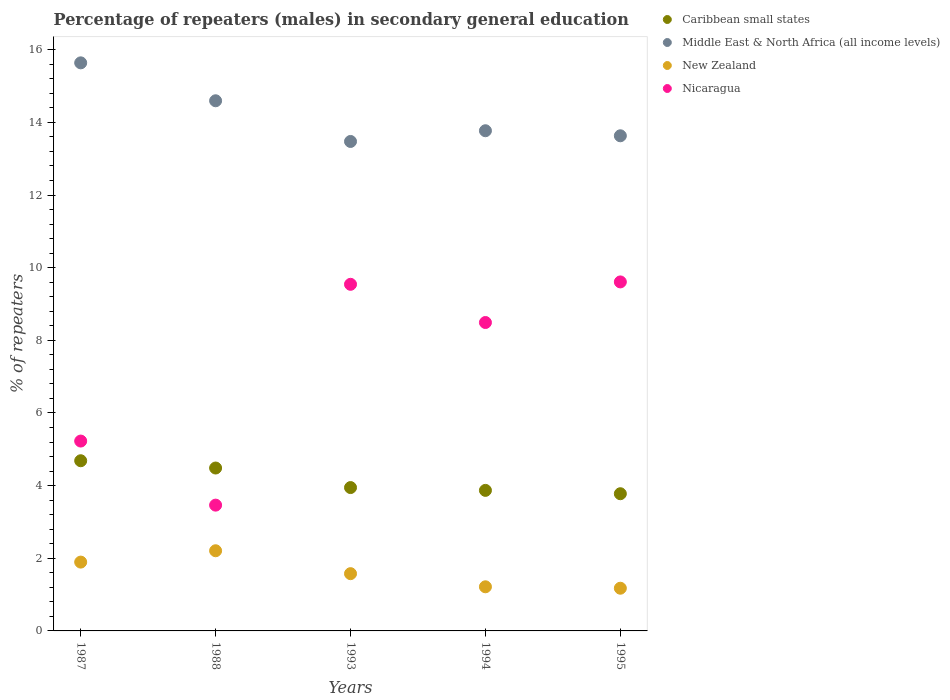How many different coloured dotlines are there?
Provide a short and direct response. 4. Is the number of dotlines equal to the number of legend labels?
Your response must be concise. Yes. What is the percentage of male repeaters in Nicaragua in 1995?
Offer a terse response. 9.61. Across all years, what is the maximum percentage of male repeaters in Nicaragua?
Provide a short and direct response. 9.61. Across all years, what is the minimum percentage of male repeaters in Nicaragua?
Your response must be concise. 3.46. In which year was the percentage of male repeaters in New Zealand maximum?
Make the answer very short. 1988. What is the total percentage of male repeaters in New Zealand in the graph?
Your answer should be very brief. 8.07. What is the difference between the percentage of male repeaters in Caribbean small states in 1993 and that in 1994?
Offer a very short reply. 0.08. What is the difference between the percentage of male repeaters in New Zealand in 1988 and the percentage of male repeaters in Nicaragua in 1987?
Your answer should be compact. -3.02. What is the average percentage of male repeaters in New Zealand per year?
Your response must be concise. 1.61. In the year 1987, what is the difference between the percentage of male repeaters in Middle East & North Africa (all income levels) and percentage of male repeaters in Caribbean small states?
Offer a terse response. 10.95. What is the ratio of the percentage of male repeaters in Middle East & North Africa (all income levels) in 1987 to that in 1994?
Your response must be concise. 1.14. What is the difference between the highest and the second highest percentage of male repeaters in Middle East & North Africa (all income levels)?
Provide a succinct answer. 1.04. What is the difference between the highest and the lowest percentage of male repeaters in Caribbean small states?
Keep it short and to the point. 0.91. Is it the case that in every year, the sum of the percentage of male repeaters in Caribbean small states and percentage of male repeaters in New Zealand  is greater than the sum of percentage of male repeaters in Nicaragua and percentage of male repeaters in Middle East & North Africa (all income levels)?
Offer a terse response. No. Is it the case that in every year, the sum of the percentage of male repeaters in Middle East & North Africa (all income levels) and percentage of male repeaters in Nicaragua  is greater than the percentage of male repeaters in Caribbean small states?
Offer a terse response. Yes. Does the percentage of male repeaters in Middle East & North Africa (all income levels) monotonically increase over the years?
Make the answer very short. No. How many legend labels are there?
Your response must be concise. 4. What is the title of the graph?
Keep it short and to the point. Percentage of repeaters (males) in secondary general education. What is the label or title of the X-axis?
Provide a succinct answer. Years. What is the label or title of the Y-axis?
Provide a succinct answer. % of repeaters. What is the % of repeaters of Caribbean small states in 1987?
Provide a short and direct response. 4.68. What is the % of repeaters of Middle East & North Africa (all income levels) in 1987?
Offer a terse response. 15.64. What is the % of repeaters in New Zealand in 1987?
Your answer should be compact. 1.89. What is the % of repeaters of Nicaragua in 1987?
Give a very brief answer. 5.23. What is the % of repeaters in Caribbean small states in 1988?
Make the answer very short. 4.48. What is the % of repeaters in Middle East & North Africa (all income levels) in 1988?
Ensure brevity in your answer.  14.59. What is the % of repeaters in New Zealand in 1988?
Keep it short and to the point. 2.21. What is the % of repeaters of Nicaragua in 1988?
Provide a short and direct response. 3.46. What is the % of repeaters of Caribbean small states in 1993?
Keep it short and to the point. 3.95. What is the % of repeaters in Middle East & North Africa (all income levels) in 1993?
Offer a very short reply. 13.47. What is the % of repeaters of New Zealand in 1993?
Your answer should be compact. 1.58. What is the % of repeaters of Nicaragua in 1993?
Your response must be concise. 9.54. What is the % of repeaters in Caribbean small states in 1994?
Make the answer very short. 3.87. What is the % of repeaters in Middle East & North Africa (all income levels) in 1994?
Keep it short and to the point. 13.77. What is the % of repeaters in New Zealand in 1994?
Make the answer very short. 1.21. What is the % of repeaters in Nicaragua in 1994?
Your response must be concise. 8.49. What is the % of repeaters in Caribbean small states in 1995?
Provide a short and direct response. 3.78. What is the % of repeaters in Middle East & North Africa (all income levels) in 1995?
Give a very brief answer. 13.63. What is the % of repeaters in New Zealand in 1995?
Provide a short and direct response. 1.18. What is the % of repeaters of Nicaragua in 1995?
Provide a succinct answer. 9.61. Across all years, what is the maximum % of repeaters of Caribbean small states?
Provide a succinct answer. 4.68. Across all years, what is the maximum % of repeaters in Middle East & North Africa (all income levels)?
Your answer should be very brief. 15.64. Across all years, what is the maximum % of repeaters in New Zealand?
Your answer should be very brief. 2.21. Across all years, what is the maximum % of repeaters in Nicaragua?
Provide a short and direct response. 9.61. Across all years, what is the minimum % of repeaters in Caribbean small states?
Provide a succinct answer. 3.78. Across all years, what is the minimum % of repeaters in Middle East & North Africa (all income levels)?
Make the answer very short. 13.47. Across all years, what is the minimum % of repeaters in New Zealand?
Your answer should be compact. 1.18. Across all years, what is the minimum % of repeaters of Nicaragua?
Make the answer very short. 3.46. What is the total % of repeaters in Caribbean small states in the graph?
Your response must be concise. 20.76. What is the total % of repeaters in Middle East & North Africa (all income levels) in the graph?
Your answer should be very brief. 71.1. What is the total % of repeaters of New Zealand in the graph?
Offer a very short reply. 8.07. What is the total % of repeaters in Nicaragua in the graph?
Your answer should be very brief. 36.33. What is the difference between the % of repeaters in Caribbean small states in 1987 and that in 1988?
Ensure brevity in your answer.  0.2. What is the difference between the % of repeaters in Middle East & North Africa (all income levels) in 1987 and that in 1988?
Offer a very short reply. 1.04. What is the difference between the % of repeaters of New Zealand in 1987 and that in 1988?
Your response must be concise. -0.31. What is the difference between the % of repeaters of Nicaragua in 1987 and that in 1988?
Your answer should be compact. 1.76. What is the difference between the % of repeaters in Caribbean small states in 1987 and that in 1993?
Your answer should be very brief. 0.74. What is the difference between the % of repeaters in Middle East & North Africa (all income levels) in 1987 and that in 1993?
Provide a succinct answer. 2.16. What is the difference between the % of repeaters of New Zealand in 1987 and that in 1993?
Your answer should be compact. 0.32. What is the difference between the % of repeaters in Nicaragua in 1987 and that in 1993?
Offer a very short reply. -4.32. What is the difference between the % of repeaters of Caribbean small states in 1987 and that in 1994?
Offer a terse response. 0.82. What is the difference between the % of repeaters of Middle East & North Africa (all income levels) in 1987 and that in 1994?
Offer a very short reply. 1.87. What is the difference between the % of repeaters in New Zealand in 1987 and that in 1994?
Your answer should be very brief. 0.68. What is the difference between the % of repeaters of Nicaragua in 1987 and that in 1994?
Offer a very short reply. -3.26. What is the difference between the % of repeaters of Caribbean small states in 1987 and that in 1995?
Your response must be concise. 0.91. What is the difference between the % of repeaters of Middle East & North Africa (all income levels) in 1987 and that in 1995?
Keep it short and to the point. 2.01. What is the difference between the % of repeaters in New Zealand in 1987 and that in 1995?
Offer a terse response. 0.72. What is the difference between the % of repeaters of Nicaragua in 1987 and that in 1995?
Offer a terse response. -4.38. What is the difference between the % of repeaters in Caribbean small states in 1988 and that in 1993?
Provide a succinct answer. 0.54. What is the difference between the % of repeaters of Middle East & North Africa (all income levels) in 1988 and that in 1993?
Your answer should be very brief. 1.12. What is the difference between the % of repeaters in New Zealand in 1988 and that in 1993?
Provide a short and direct response. 0.63. What is the difference between the % of repeaters in Nicaragua in 1988 and that in 1993?
Your answer should be very brief. -6.08. What is the difference between the % of repeaters of Caribbean small states in 1988 and that in 1994?
Give a very brief answer. 0.62. What is the difference between the % of repeaters in Middle East & North Africa (all income levels) in 1988 and that in 1994?
Provide a short and direct response. 0.82. What is the difference between the % of repeaters of New Zealand in 1988 and that in 1994?
Offer a terse response. 0.99. What is the difference between the % of repeaters of Nicaragua in 1988 and that in 1994?
Provide a short and direct response. -5.03. What is the difference between the % of repeaters of Caribbean small states in 1988 and that in 1995?
Keep it short and to the point. 0.71. What is the difference between the % of repeaters in Middle East & North Africa (all income levels) in 1988 and that in 1995?
Offer a terse response. 0.96. What is the difference between the % of repeaters of New Zealand in 1988 and that in 1995?
Your answer should be compact. 1.03. What is the difference between the % of repeaters in Nicaragua in 1988 and that in 1995?
Ensure brevity in your answer.  -6.14. What is the difference between the % of repeaters of Caribbean small states in 1993 and that in 1994?
Keep it short and to the point. 0.08. What is the difference between the % of repeaters in Middle East & North Africa (all income levels) in 1993 and that in 1994?
Your answer should be very brief. -0.3. What is the difference between the % of repeaters in New Zealand in 1993 and that in 1994?
Keep it short and to the point. 0.36. What is the difference between the % of repeaters in Nicaragua in 1993 and that in 1994?
Ensure brevity in your answer.  1.05. What is the difference between the % of repeaters in Caribbean small states in 1993 and that in 1995?
Your answer should be compact. 0.17. What is the difference between the % of repeaters of Middle East & North Africa (all income levels) in 1993 and that in 1995?
Your answer should be very brief. -0.16. What is the difference between the % of repeaters in New Zealand in 1993 and that in 1995?
Offer a terse response. 0.4. What is the difference between the % of repeaters of Nicaragua in 1993 and that in 1995?
Provide a short and direct response. -0.07. What is the difference between the % of repeaters of Caribbean small states in 1994 and that in 1995?
Your answer should be very brief. 0.09. What is the difference between the % of repeaters in Middle East & North Africa (all income levels) in 1994 and that in 1995?
Provide a short and direct response. 0.14. What is the difference between the % of repeaters of New Zealand in 1994 and that in 1995?
Keep it short and to the point. 0.04. What is the difference between the % of repeaters of Nicaragua in 1994 and that in 1995?
Keep it short and to the point. -1.12. What is the difference between the % of repeaters in Caribbean small states in 1987 and the % of repeaters in Middle East & North Africa (all income levels) in 1988?
Offer a terse response. -9.91. What is the difference between the % of repeaters of Caribbean small states in 1987 and the % of repeaters of New Zealand in 1988?
Offer a terse response. 2.48. What is the difference between the % of repeaters of Caribbean small states in 1987 and the % of repeaters of Nicaragua in 1988?
Your answer should be very brief. 1.22. What is the difference between the % of repeaters of Middle East & North Africa (all income levels) in 1987 and the % of repeaters of New Zealand in 1988?
Provide a short and direct response. 13.43. What is the difference between the % of repeaters in Middle East & North Africa (all income levels) in 1987 and the % of repeaters in Nicaragua in 1988?
Provide a short and direct response. 12.18. What is the difference between the % of repeaters of New Zealand in 1987 and the % of repeaters of Nicaragua in 1988?
Your answer should be compact. -1.57. What is the difference between the % of repeaters of Caribbean small states in 1987 and the % of repeaters of Middle East & North Africa (all income levels) in 1993?
Keep it short and to the point. -8.79. What is the difference between the % of repeaters of Caribbean small states in 1987 and the % of repeaters of New Zealand in 1993?
Offer a very short reply. 3.11. What is the difference between the % of repeaters of Caribbean small states in 1987 and the % of repeaters of Nicaragua in 1993?
Your answer should be compact. -4.86. What is the difference between the % of repeaters of Middle East & North Africa (all income levels) in 1987 and the % of repeaters of New Zealand in 1993?
Your response must be concise. 14.06. What is the difference between the % of repeaters in Middle East & North Africa (all income levels) in 1987 and the % of repeaters in Nicaragua in 1993?
Your answer should be compact. 6.1. What is the difference between the % of repeaters in New Zealand in 1987 and the % of repeaters in Nicaragua in 1993?
Make the answer very short. -7.65. What is the difference between the % of repeaters in Caribbean small states in 1987 and the % of repeaters in Middle East & North Africa (all income levels) in 1994?
Ensure brevity in your answer.  -9.08. What is the difference between the % of repeaters in Caribbean small states in 1987 and the % of repeaters in New Zealand in 1994?
Provide a succinct answer. 3.47. What is the difference between the % of repeaters in Caribbean small states in 1987 and the % of repeaters in Nicaragua in 1994?
Give a very brief answer. -3.81. What is the difference between the % of repeaters in Middle East & North Africa (all income levels) in 1987 and the % of repeaters in New Zealand in 1994?
Provide a short and direct response. 14.42. What is the difference between the % of repeaters in Middle East & North Africa (all income levels) in 1987 and the % of repeaters in Nicaragua in 1994?
Offer a very short reply. 7.15. What is the difference between the % of repeaters in New Zealand in 1987 and the % of repeaters in Nicaragua in 1994?
Provide a succinct answer. -6.6. What is the difference between the % of repeaters in Caribbean small states in 1987 and the % of repeaters in Middle East & North Africa (all income levels) in 1995?
Ensure brevity in your answer.  -8.95. What is the difference between the % of repeaters of Caribbean small states in 1987 and the % of repeaters of New Zealand in 1995?
Give a very brief answer. 3.51. What is the difference between the % of repeaters in Caribbean small states in 1987 and the % of repeaters in Nicaragua in 1995?
Offer a terse response. -4.92. What is the difference between the % of repeaters of Middle East & North Africa (all income levels) in 1987 and the % of repeaters of New Zealand in 1995?
Your answer should be compact. 14.46. What is the difference between the % of repeaters in Middle East & North Africa (all income levels) in 1987 and the % of repeaters in Nicaragua in 1995?
Ensure brevity in your answer.  6.03. What is the difference between the % of repeaters in New Zealand in 1987 and the % of repeaters in Nicaragua in 1995?
Your answer should be very brief. -7.71. What is the difference between the % of repeaters of Caribbean small states in 1988 and the % of repeaters of Middle East & North Africa (all income levels) in 1993?
Offer a terse response. -8.99. What is the difference between the % of repeaters in Caribbean small states in 1988 and the % of repeaters in New Zealand in 1993?
Offer a very short reply. 2.91. What is the difference between the % of repeaters in Caribbean small states in 1988 and the % of repeaters in Nicaragua in 1993?
Offer a terse response. -5.06. What is the difference between the % of repeaters in Middle East & North Africa (all income levels) in 1988 and the % of repeaters in New Zealand in 1993?
Keep it short and to the point. 13.02. What is the difference between the % of repeaters of Middle East & North Africa (all income levels) in 1988 and the % of repeaters of Nicaragua in 1993?
Provide a succinct answer. 5.05. What is the difference between the % of repeaters in New Zealand in 1988 and the % of repeaters in Nicaragua in 1993?
Your response must be concise. -7.33. What is the difference between the % of repeaters of Caribbean small states in 1988 and the % of repeaters of Middle East & North Africa (all income levels) in 1994?
Provide a short and direct response. -9.28. What is the difference between the % of repeaters of Caribbean small states in 1988 and the % of repeaters of New Zealand in 1994?
Your answer should be compact. 3.27. What is the difference between the % of repeaters in Caribbean small states in 1988 and the % of repeaters in Nicaragua in 1994?
Offer a very short reply. -4.01. What is the difference between the % of repeaters of Middle East & North Africa (all income levels) in 1988 and the % of repeaters of New Zealand in 1994?
Your response must be concise. 13.38. What is the difference between the % of repeaters of Middle East & North Africa (all income levels) in 1988 and the % of repeaters of Nicaragua in 1994?
Your answer should be compact. 6.1. What is the difference between the % of repeaters of New Zealand in 1988 and the % of repeaters of Nicaragua in 1994?
Give a very brief answer. -6.28. What is the difference between the % of repeaters in Caribbean small states in 1988 and the % of repeaters in Middle East & North Africa (all income levels) in 1995?
Provide a short and direct response. -9.15. What is the difference between the % of repeaters of Caribbean small states in 1988 and the % of repeaters of New Zealand in 1995?
Your response must be concise. 3.31. What is the difference between the % of repeaters of Caribbean small states in 1988 and the % of repeaters of Nicaragua in 1995?
Give a very brief answer. -5.12. What is the difference between the % of repeaters in Middle East & North Africa (all income levels) in 1988 and the % of repeaters in New Zealand in 1995?
Keep it short and to the point. 13.42. What is the difference between the % of repeaters in Middle East & North Africa (all income levels) in 1988 and the % of repeaters in Nicaragua in 1995?
Your answer should be very brief. 4.99. What is the difference between the % of repeaters of New Zealand in 1988 and the % of repeaters of Nicaragua in 1995?
Your answer should be compact. -7.4. What is the difference between the % of repeaters of Caribbean small states in 1993 and the % of repeaters of Middle East & North Africa (all income levels) in 1994?
Offer a terse response. -9.82. What is the difference between the % of repeaters of Caribbean small states in 1993 and the % of repeaters of New Zealand in 1994?
Keep it short and to the point. 2.73. What is the difference between the % of repeaters of Caribbean small states in 1993 and the % of repeaters of Nicaragua in 1994?
Keep it short and to the point. -4.54. What is the difference between the % of repeaters in Middle East & North Africa (all income levels) in 1993 and the % of repeaters in New Zealand in 1994?
Your response must be concise. 12.26. What is the difference between the % of repeaters in Middle East & North Africa (all income levels) in 1993 and the % of repeaters in Nicaragua in 1994?
Your response must be concise. 4.98. What is the difference between the % of repeaters of New Zealand in 1993 and the % of repeaters of Nicaragua in 1994?
Your response must be concise. -6.91. What is the difference between the % of repeaters in Caribbean small states in 1993 and the % of repeaters in Middle East & North Africa (all income levels) in 1995?
Your answer should be compact. -9.68. What is the difference between the % of repeaters of Caribbean small states in 1993 and the % of repeaters of New Zealand in 1995?
Offer a terse response. 2.77. What is the difference between the % of repeaters of Caribbean small states in 1993 and the % of repeaters of Nicaragua in 1995?
Make the answer very short. -5.66. What is the difference between the % of repeaters of Middle East & North Africa (all income levels) in 1993 and the % of repeaters of New Zealand in 1995?
Give a very brief answer. 12.3. What is the difference between the % of repeaters of Middle East & North Africa (all income levels) in 1993 and the % of repeaters of Nicaragua in 1995?
Offer a terse response. 3.87. What is the difference between the % of repeaters in New Zealand in 1993 and the % of repeaters in Nicaragua in 1995?
Make the answer very short. -8.03. What is the difference between the % of repeaters of Caribbean small states in 1994 and the % of repeaters of Middle East & North Africa (all income levels) in 1995?
Your answer should be very brief. -9.76. What is the difference between the % of repeaters in Caribbean small states in 1994 and the % of repeaters in New Zealand in 1995?
Ensure brevity in your answer.  2.69. What is the difference between the % of repeaters of Caribbean small states in 1994 and the % of repeaters of Nicaragua in 1995?
Ensure brevity in your answer.  -5.74. What is the difference between the % of repeaters of Middle East & North Africa (all income levels) in 1994 and the % of repeaters of New Zealand in 1995?
Make the answer very short. 12.59. What is the difference between the % of repeaters in Middle East & North Africa (all income levels) in 1994 and the % of repeaters in Nicaragua in 1995?
Offer a terse response. 4.16. What is the difference between the % of repeaters in New Zealand in 1994 and the % of repeaters in Nicaragua in 1995?
Give a very brief answer. -8.39. What is the average % of repeaters in Caribbean small states per year?
Make the answer very short. 4.15. What is the average % of repeaters in Middle East & North Africa (all income levels) per year?
Your response must be concise. 14.22. What is the average % of repeaters in New Zealand per year?
Provide a succinct answer. 1.61. What is the average % of repeaters of Nicaragua per year?
Provide a succinct answer. 7.27. In the year 1987, what is the difference between the % of repeaters in Caribbean small states and % of repeaters in Middle East & North Africa (all income levels)?
Ensure brevity in your answer.  -10.95. In the year 1987, what is the difference between the % of repeaters of Caribbean small states and % of repeaters of New Zealand?
Make the answer very short. 2.79. In the year 1987, what is the difference between the % of repeaters in Caribbean small states and % of repeaters in Nicaragua?
Offer a terse response. -0.54. In the year 1987, what is the difference between the % of repeaters of Middle East & North Africa (all income levels) and % of repeaters of New Zealand?
Offer a very short reply. 13.74. In the year 1987, what is the difference between the % of repeaters of Middle East & North Africa (all income levels) and % of repeaters of Nicaragua?
Your answer should be compact. 10.41. In the year 1987, what is the difference between the % of repeaters of New Zealand and % of repeaters of Nicaragua?
Make the answer very short. -3.33. In the year 1988, what is the difference between the % of repeaters of Caribbean small states and % of repeaters of Middle East & North Africa (all income levels)?
Your answer should be compact. -10.11. In the year 1988, what is the difference between the % of repeaters in Caribbean small states and % of repeaters in New Zealand?
Keep it short and to the point. 2.28. In the year 1988, what is the difference between the % of repeaters in Caribbean small states and % of repeaters in Nicaragua?
Provide a short and direct response. 1.02. In the year 1988, what is the difference between the % of repeaters in Middle East & North Africa (all income levels) and % of repeaters in New Zealand?
Give a very brief answer. 12.39. In the year 1988, what is the difference between the % of repeaters in Middle East & North Africa (all income levels) and % of repeaters in Nicaragua?
Your answer should be compact. 11.13. In the year 1988, what is the difference between the % of repeaters in New Zealand and % of repeaters in Nicaragua?
Give a very brief answer. -1.26. In the year 1993, what is the difference between the % of repeaters in Caribbean small states and % of repeaters in Middle East & North Africa (all income levels)?
Your answer should be very brief. -9.53. In the year 1993, what is the difference between the % of repeaters in Caribbean small states and % of repeaters in New Zealand?
Keep it short and to the point. 2.37. In the year 1993, what is the difference between the % of repeaters in Caribbean small states and % of repeaters in Nicaragua?
Ensure brevity in your answer.  -5.6. In the year 1993, what is the difference between the % of repeaters of Middle East & North Africa (all income levels) and % of repeaters of New Zealand?
Your response must be concise. 11.9. In the year 1993, what is the difference between the % of repeaters of Middle East & North Africa (all income levels) and % of repeaters of Nicaragua?
Ensure brevity in your answer.  3.93. In the year 1993, what is the difference between the % of repeaters of New Zealand and % of repeaters of Nicaragua?
Provide a short and direct response. -7.97. In the year 1994, what is the difference between the % of repeaters of Caribbean small states and % of repeaters of Middle East & North Africa (all income levels)?
Provide a short and direct response. -9.9. In the year 1994, what is the difference between the % of repeaters in Caribbean small states and % of repeaters in New Zealand?
Your answer should be compact. 2.65. In the year 1994, what is the difference between the % of repeaters of Caribbean small states and % of repeaters of Nicaragua?
Keep it short and to the point. -4.62. In the year 1994, what is the difference between the % of repeaters in Middle East & North Africa (all income levels) and % of repeaters in New Zealand?
Your answer should be very brief. 12.55. In the year 1994, what is the difference between the % of repeaters in Middle East & North Africa (all income levels) and % of repeaters in Nicaragua?
Your answer should be very brief. 5.28. In the year 1994, what is the difference between the % of repeaters in New Zealand and % of repeaters in Nicaragua?
Give a very brief answer. -7.28. In the year 1995, what is the difference between the % of repeaters of Caribbean small states and % of repeaters of Middle East & North Africa (all income levels)?
Make the answer very short. -9.85. In the year 1995, what is the difference between the % of repeaters of Caribbean small states and % of repeaters of New Zealand?
Your answer should be compact. 2.6. In the year 1995, what is the difference between the % of repeaters in Caribbean small states and % of repeaters in Nicaragua?
Keep it short and to the point. -5.83. In the year 1995, what is the difference between the % of repeaters of Middle East & North Africa (all income levels) and % of repeaters of New Zealand?
Give a very brief answer. 12.45. In the year 1995, what is the difference between the % of repeaters of Middle East & North Africa (all income levels) and % of repeaters of Nicaragua?
Your answer should be compact. 4.02. In the year 1995, what is the difference between the % of repeaters of New Zealand and % of repeaters of Nicaragua?
Make the answer very short. -8.43. What is the ratio of the % of repeaters in Caribbean small states in 1987 to that in 1988?
Offer a very short reply. 1.04. What is the ratio of the % of repeaters of Middle East & North Africa (all income levels) in 1987 to that in 1988?
Make the answer very short. 1.07. What is the ratio of the % of repeaters in New Zealand in 1987 to that in 1988?
Offer a terse response. 0.86. What is the ratio of the % of repeaters of Nicaragua in 1987 to that in 1988?
Provide a short and direct response. 1.51. What is the ratio of the % of repeaters in Caribbean small states in 1987 to that in 1993?
Ensure brevity in your answer.  1.19. What is the ratio of the % of repeaters of Middle East & North Africa (all income levels) in 1987 to that in 1993?
Make the answer very short. 1.16. What is the ratio of the % of repeaters of New Zealand in 1987 to that in 1993?
Provide a succinct answer. 1.2. What is the ratio of the % of repeaters of Nicaragua in 1987 to that in 1993?
Your answer should be compact. 0.55. What is the ratio of the % of repeaters of Caribbean small states in 1987 to that in 1994?
Your response must be concise. 1.21. What is the ratio of the % of repeaters of Middle East & North Africa (all income levels) in 1987 to that in 1994?
Your answer should be compact. 1.14. What is the ratio of the % of repeaters in New Zealand in 1987 to that in 1994?
Offer a terse response. 1.56. What is the ratio of the % of repeaters of Nicaragua in 1987 to that in 1994?
Your answer should be very brief. 0.62. What is the ratio of the % of repeaters in Caribbean small states in 1987 to that in 1995?
Your response must be concise. 1.24. What is the ratio of the % of repeaters of Middle East & North Africa (all income levels) in 1987 to that in 1995?
Give a very brief answer. 1.15. What is the ratio of the % of repeaters of New Zealand in 1987 to that in 1995?
Offer a very short reply. 1.61. What is the ratio of the % of repeaters of Nicaragua in 1987 to that in 1995?
Offer a very short reply. 0.54. What is the ratio of the % of repeaters in Caribbean small states in 1988 to that in 1993?
Your answer should be compact. 1.14. What is the ratio of the % of repeaters in Middle East & North Africa (all income levels) in 1988 to that in 1993?
Give a very brief answer. 1.08. What is the ratio of the % of repeaters in New Zealand in 1988 to that in 1993?
Provide a short and direct response. 1.4. What is the ratio of the % of repeaters in Nicaragua in 1988 to that in 1993?
Your answer should be very brief. 0.36. What is the ratio of the % of repeaters in Caribbean small states in 1988 to that in 1994?
Offer a very short reply. 1.16. What is the ratio of the % of repeaters of Middle East & North Africa (all income levels) in 1988 to that in 1994?
Your answer should be compact. 1.06. What is the ratio of the % of repeaters of New Zealand in 1988 to that in 1994?
Keep it short and to the point. 1.82. What is the ratio of the % of repeaters of Nicaragua in 1988 to that in 1994?
Offer a terse response. 0.41. What is the ratio of the % of repeaters of Caribbean small states in 1988 to that in 1995?
Provide a succinct answer. 1.19. What is the ratio of the % of repeaters of Middle East & North Africa (all income levels) in 1988 to that in 1995?
Provide a short and direct response. 1.07. What is the ratio of the % of repeaters of New Zealand in 1988 to that in 1995?
Make the answer very short. 1.88. What is the ratio of the % of repeaters of Nicaragua in 1988 to that in 1995?
Ensure brevity in your answer.  0.36. What is the ratio of the % of repeaters in Caribbean small states in 1993 to that in 1994?
Make the answer very short. 1.02. What is the ratio of the % of repeaters in Middle East & North Africa (all income levels) in 1993 to that in 1994?
Your answer should be very brief. 0.98. What is the ratio of the % of repeaters of New Zealand in 1993 to that in 1994?
Give a very brief answer. 1.3. What is the ratio of the % of repeaters of Nicaragua in 1993 to that in 1994?
Provide a short and direct response. 1.12. What is the ratio of the % of repeaters in Caribbean small states in 1993 to that in 1995?
Your answer should be compact. 1.04. What is the ratio of the % of repeaters in New Zealand in 1993 to that in 1995?
Ensure brevity in your answer.  1.34. What is the ratio of the % of repeaters in Caribbean small states in 1994 to that in 1995?
Your response must be concise. 1.02. What is the ratio of the % of repeaters of Middle East & North Africa (all income levels) in 1994 to that in 1995?
Offer a terse response. 1.01. What is the ratio of the % of repeaters of New Zealand in 1994 to that in 1995?
Offer a very short reply. 1.03. What is the ratio of the % of repeaters of Nicaragua in 1994 to that in 1995?
Offer a terse response. 0.88. What is the difference between the highest and the second highest % of repeaters in Caribbean small states?
Keep it short and to the point. 0.2. What is the difference between the highest and the second highest % of repeaters in Middle East & North Africa (all income levels)?
Ensure brevity in your answer.  1.04. What is the difference between the highest and the second highest % of repeaters in New Zealand?
Give a very brief answer. 0.31. What is the difference between the highest and the second highest % of repeaters of Nicaragua?
Keep it short and to the point. 0.07. What is the difference between the highest and the lowest % of repeaters in Caribbean small states?
Offer a terse response. 0.91. What is the difference between the highest and the lowest % of repeaters in Middle East & North Africa (all income levels)?
Offer a very short reply. 2.16. What is the difference between the highest and the lowest % of repeaters in New Zealand?
Keep it short and to the point. 1.03. What is the difference between the highest and the lowest % of repeaters of Nicaragua?
Provide a succinct answer. 6.14. 